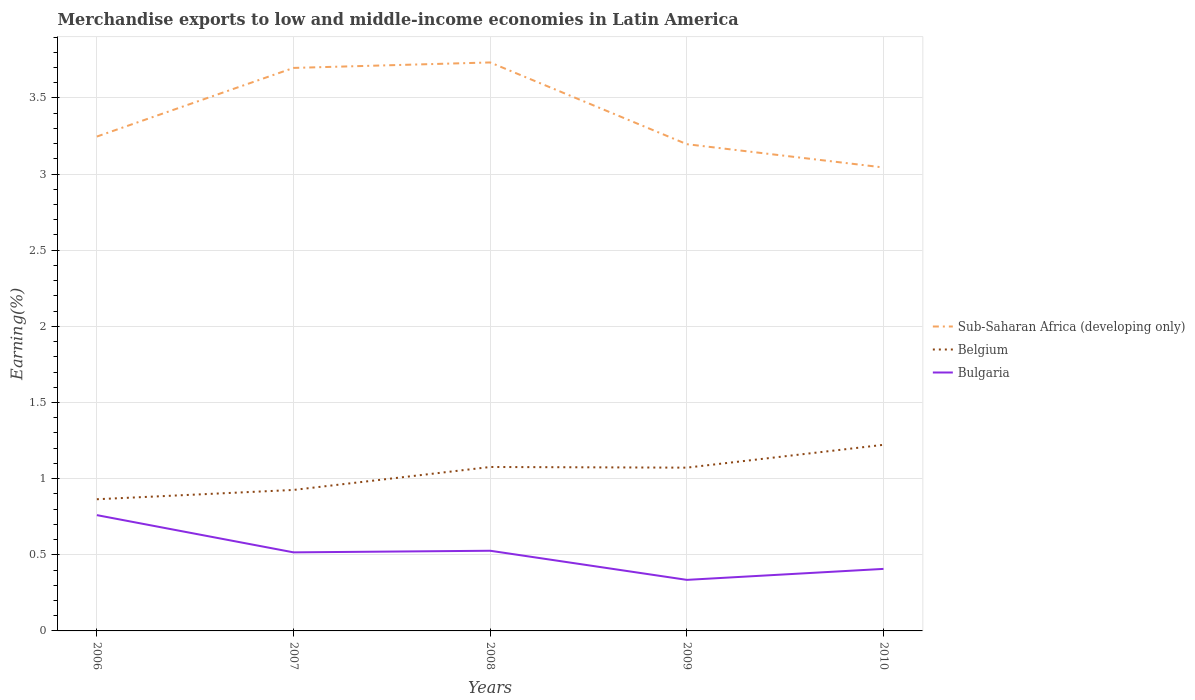Does the line corresponding to Sub-Saharan Africa (developing only) intersect with the line corresponding to Belgium?
Give a very brief answer. No. Is the number of lines equal to the number of legend labels?
Keep it short and to the point. Yes. Across all years, what is the maximum percentage of amount earned from merchandise exports in Bulgaria?
Provide a succinct answer. 0.34. In which year was the percentage of amount earned from merchandise exports in Bulgaria maximum?
Ensure brevity in your answer.  2009. What is the total percentage of amount earned from merchandise exports in Sub-Saharan Africa (developing only) in the graph?
Offer a very short reply. 0.5. What is the difference between the highest and the second highest percentage of amount earned from merchandise exports in Bulgaria?
Make the answer very short. 0.43. What is the difference between the highest and the lowest percentage of amount earned from merchandise exports in Belgium?
Keep it short and to the point. 3. How many years are there in the graph?
Your answer should be very brief. 5. Are the values on the major ticks of Y-axis written in scientific E-notation?
Keep it short and to the point. No. What is the title of the graph?
Offer a terse response. Merchandise exports to low and middle-income economies in Latin America. Does "Northern Mariana Islands" appear as one of the legend labels in the graph?
Offer a very short reply. No. What is the label or title of the X-axis?
Ensure brevity in your answer.  Years. What is the label or title of the Y-axis?
Your answer should be very brief. Earning(%). What is the Earning(%) of Sub-Saharan Africa (developing only) in 2006?
Offer a very short reply. 3.25. What is the Earning(%) of Belgium in 2006?
Provide a succinct answer. 0.86. What is the Earning(%) of Bulgaria in 2006?
Make the answer very short. 0.76. What is the Earning(%) of Sub-Saharan Africa (developing only) in 2007?
Your response must be concise. 3.7. What is the Earning(%) of Belgium in 2007?
Your answer should be compact. 0.93. What is the Earning(%) in Bulgaria in 2007?
Ensure brevity in your answer.  0.52. What is the Earning(%) in Sub-Saharan Africa (developing only) in 2008?
Ensure brevity in your answer.  3.73. What is the Earning(%) of Belgium in 2008?
Your response must be concise. 1.08. What is the Earning(%) of Bulgaria in 2008?
Keep it short and to the point. 0.53. What is the Earning(%) of Sub-Saharan Africa (developing only) in 2009?
Give a very brief answer. 3.2. What is the Earning(%) of Belgium in 2009?
Give a very brief answer. 1.07. What is the Earning(%) in Bulgaria in 2009?
Your answer should be very brief. 0.34. What is the Earning(%) of Sub-Saharan Africa (developing only) in 2010?
Give a very brief answer. 3.04. What is the Earning(%) in Belgium in 2010?
Offer a very short reply. 1.22. What is the Earning(%) in Bulgaria in 2010?
Give a very brief answer. 0.41. Across all years, what is the maximum Earning(%) in Sub-Saharan Africa (developing only)?
Offer a terse response. 3.73. Across all years, what is the maximum Earning(%) in Belgium?
Keep it short and to the point. 1.22. Across all years, what is the maximum Earning(%) of Bulgaria?
Keep it short and to the point. 0.76. Across all years, what is the minimum Earning(%) of Sub-Saharan Africa (developing only)?
Ensure brevity in your answer.  3.04. Across all years, what is the minimum Earning(%) in Belgium?
Your response must be concise. 0.86. Across all years, what is the minimum Earning(%) of Bulgaria?
Provide a succinct answer. 0.34. What is the total Earning(%) in Sub-Saharan Africa (developing only) in the graph?
Offer a terse response. 16.92. What is the total Earning(%) in Belgium in the graph?
Offer a terse response. 5.16. What is the total Earning(%) in Bulgaria in the graph?
Offer a very short reply. 2.55. What is the difference between the Earning(%) of Sub-Saharan Africa (developing only) in 2006 and that in 2007?
Your answer should be compact. -0.45. What is the difference between the Earning(%) in Belgium in 2006 and that in 2007?
Offer a terse response. -0.06. What is the difference between the Earning(%) in Bulgaria in 2006 and that in 2007?
Give a very brief answer. 0.24. What is the difference between the Earning(%) of Sub-Saharan Africa (developing only) in 2006 and that in 2008?
Your answer should be compact. -0.49. What is the difference between the Earning(%) of Belgium in 2006 and that in 2008?
Offer a very short reply. -0.21. What is the difference between the Earning(%) in Bulgaria in 2006 and that in 2008?
Offer a terse response. 0.23. What is the difference between the Earning(%) of Sub-Saharan Africa (developing only) in 2006 and that in 2009?
Your answer should be compact. 0.05. What is the difference between the Earning(%) of Belgium in 2006 and that in 2009?
Offer a terse response. -0.21. What is the difference between the Earning(%) of Bulgaria in 2006 and that in 2009?
Make the answer very short. 0.43. What is the difference between the Earning(%) in Sub-Saharan Africa (developing only) in 2006 and that in 2010?
Your answer should be very brief. 0.2. What is the difference between the Earning(%) in Belgium in 2006 and that in 2010?
Provide a short and direct response. -0.36. What is the difference between the Earning(%) in Bulgaria in 2006 and that in 2010?
Give a very brief answer. 0.35. What is the difference between the Earning(%) in Sub-Saharan Africa (developing only) in 2007 and that in 2008?
Keep it short and to the point. -0.04. What is the difference between the Earning(%) of Belgium in 2007 and that in 2008?
Ensure brevity in your answer.  -0.15. What is the difference between the Earning(%) in Bulgaria in 2007 and that in 2008?
Give a very brief answer. -0.01. What is the difference between the Earning(%) of Sub-Saharan Africa (developing only) in 2007 and that in 2009?
Make the answer very short. 0.5. What is the difference between the Earning(%) of Belgium in 2007 and that in 2009?
Provide a short and direct response. -0.15. What is the difference between the Earning(%) of Bulgaria in 2007 and that in 2009?
Your answer should be compact. 0.18. What is the difference between the Earning(%) of Sub-Saharan Africa (developing only) in 2007 and that in 2010?
Offer a terse response. 0.65. What is the difference between the Earning(%) in Belgium in 2007 and that in 2010?
Offer a very short reply. -0.3. What is the difference between the Earning(%) of Bulgaria in 2007 and that in 2010?
Your answer should be compact. 0.11. What is the difference between the Earning(%) in Sub-Saharan Africa (developing only) in 2008 and that in 2009?
Make the answer very short. 0.54. What is the difference between the Earning(%) in Belgium in 2008 and that in 2009?
Give a very brief answer. 0. What is the difference between the Earning(%) of Bulgaria in 2008 and that in 2009?
Offer a terse response. 0.19. What is the difference between the Earning(%) of Sub-Saharan Africa (developing only) in 2008 and that in 2010?
Provide a succinct answer. 0.69. What is the difference between the Earning(%) in Belgium in 2008 and that in 2010?
Offer a very short reply. -0.15. What is the difference between the Earning(%) in Bulgaria in 2008 and that in 2010?
Your response must be concise. 0.12. What is the difference between the Earning(%) in Sub-Saharan Africa (developing only) in 2009 and that in 2010?
Provide a short and direct response. 0.15. What is the difference between the Earning(%) in Belgium in 2009 and that in 2010?
Ensure brevity in your answer.  -0.15. What is the difference between the Earning(%) in Bulgaria in 2009 and that in 2010?
Your answer should be compact. -0.07. What is the difference between the Earning(%) in Sub-Saharan Africa (developing only) in 2006 and the Earning(%) in Belgium in 2007?
Offer a terse response. 2.32. What is the difference between the Earning(%) of Sub-Saharan Africa (developing only) in 2006 and the Earning(%) of Bulgaria in 2007?
Your answer should be compact. 2.73. What is the difference between the Earning(%) in Belgium in 2006 and the Earning(%) in Bulgaria in 2007?
Offer a terse response. 0.35. What is the difference between the Earning(%) of Sub-Saharan Africa (developing only) in 2006 and the Earning(%) of Belgium in 2008?
Keep it short and to the point. 2.17. What is the difference between the Earning(%) in Sub-Saharan Africa (developing only) in 2006 and the Earning(%) in Bulgaria in 2008?
Offer a very short reply. 2.72. What is the difference between the Earning(%) in Belgium in 2006 and the Earning(%) in Bulgaria in 2008?
Provide a short and direct response. 0.34. What is the difference between the Earning(%) in Sub-Saharan Africa (developing only) in 2006 and the Earning(%) in Belgium in 2009?
Offer a very short reply. 2.17. What is the difference between the Earning(%) in Sub-Saharan Africa (developing only) in 2006 and the Earning(%) in Bulgaria in 2009?
Your answer should be very brief. 2.91. What is the difference between the Earning(%) in Belgium in 2006 and the Earning(%) in Bulgaria in 2009?
Ensure brevity in your answer.  0.53. What is the difference between the Earning(%) in Sub-Saharan Africa (developing only) in 2006 and the Earning(%) in Belgium in 2010?
Keep it short and to the point. 2.02. What is the difference between the Earning(%) of Sub-Saharan Africa (developing only) in 2006 and the Earning(%) of Bulgaria in 2010?
Offer a terse response. 2.84. What is the difference between the Earning(%) of Belgium in 2006 and the Earning(%) of Bulgaria in 2010?
Offer a terse response. 0.46. What is the difference between the Earning(%) in Sub-Saharan Africa (developing only) in 2007 and the Earning(%) in Belgium in 2008?
Provide a succinct answer. 2.62. What is the difference between the Earning(%) in Sub-Saharan Africa (developing only) in 2007 and the Earning(%) in Bulgaria in 2008?
Give a very brief answer. 3.17. What is the difference between the Earning(%) of Belgium in 2007 and the Earning(%) of Bulgaria in 2008?
Your response must be concise. 0.4. What is the difference between the Earning(%) in Sub-Saharan Africa (developing only) in 2007 and the Earning(%) in Belgium in 2009?
Give a very brief answer. 2.62. What is the difference between the Earning(%) of Sub-Saharan Africa (developing only) in 2007 and the Earning(%) of Bulgaria in 2009?
Keep it short and to the point. 3.36. What is the difference between the Earning(%) of Belgium in 2007 and the Earning(%) of Bulgaria in 2009?
Offer a very short reply. 0.59. What is the difference between the Earning(%) in Sub-Saharan Africa (developing only) in 2007 and the Earning(%) in Belgium in 2010?
Keep it short and to the point. 2.48. What is the difference between the Earning(%) in Sub-Saharan Africa (developing only) in 2007 and the Earning(%) in Bulgaria in 2010?
Your response must be concise. 3.29. What is the difference between the Earning(%) in Belgium in 2007 and the Earning(%) in Bulgaria in 2010?
Provide a succinct answer. 0.52. What is the difference between the Earning(%) of Sub-Saharan Africa (developing only) in 2008 and the Earning(%) of Belgium in 2009?
Ensure brevity in your answer.  2.66. What is the difference between the Earning(%) of Sub-Saharan Africa (developing only) in 2008 and the Earning(%) of Bulgaria in 2009?
Your answer should be very brief. 3.4. What is the difference between the Earning(%) of Belgium in 2008 and the Earning(%) of Bulgaria in 2009?
Ensure brevity in your answer.  0.74. What is the difference between the Earning(%) of Sub-Saharan Africa (developing only) in 2008 and the Earning(%) of Belgium in 2010?
Your answer should be very brief. 2.51. What is the difference between the Earning(%) of Sub-Saharan Africa (developing only) in 2008 and the Earning(%) of Bulgaria in 2010?
Your response must be concise. 3.33. What is the difference between the Earning(%) of Belgium in 2008 and the Earning(%) of Bulgaria in 2010?
Provide a succinct answer. 0.67. What is the difference between the Earning(%) in Sub-Saharan Africa (developing only) in 2009 and the Earning(%) in Belgium in 2010?
Ensure brevity in your answer.  1.97. What is the difference between the Earning(%) of Sub-Saharan Africa (developing only) in 2009 and the Earning(%) of Bulgaria in 2010?
Ensure brevity in your answer.  2.79. What is the difference between the Earning(%) in Belgium in 2009 and the Earning(%) in Bulgaria in 2010?
Offer a terse response. 0.66. What is the average Earning(%) in Sub-Saharan Africa (developing only) per year?
Provide a succinct answer. 3.38. What is the average Earning(%) in Belgium per year?
Your answer should be very brief. 1.03. What is the average Earning(%) in Bulgaria per year?
Your response must be concise. 0.51. In the year 2006, what is the difference between the Earning(%) in Sub-Saharan Africa (developing only) and Earning(%) in Belgium?
Ensure brevity in your answer.  2.38. In the year 2006, what is the difference between the Earning(%) in Sub-Saharan Africa (developing only) and Earning(%) in Bulgaria?
Ensure brevity in your answer.  2.49. In the year 2006, what is the difference between the Earning(%) of Belgium and Earning(%) of Bulgaria?
Ensure brevity in your answer.  0.1. In the year 2007, what is the difference between the Earning(%) in Sub-Saharan Africa (developing only) and Earning(%) in Belgium?
Your response must be concise. 2.77. In the year 2007, what is the difference between the Earning(%) of Sub-Saharan Africa (developing only) and Earning(%) of Bulgaria?
Your response must be concise. 3.18. In the year 2007, what is the difference between the Earning(%) in Belgium and Earning(%) in Bulgaria?
Your response must be concise. 0.41. In the year 2008, what is the difference between the Earning(%) in Sub-Saharan Africa (developing only) and Earning(%) in Belgium?
Give a very brief answer. 2.66. In the year 2008, what is the difference between the Earning(%) in Sub-Saharan Africa (developing only) and Earning(%) in Bulgaria?
Your answer should be very brief. 3.21. In the year 2008, what is the difference between the Earning(%) of Belgium and Earning(%) of Bulgaria?
Make the answer very short. 0.55. In the year 2009, what is the difference between the Earning(%) in Sub-Saharan Africa (developing only) and Earning(%) in Belgium?
Keep it short and to the point. 2.12. In the year 2009, what is the difference between the Earning(%) of Sub-Saharan Africa (developing only) and Earning(%) of Bulgaria?
Your answer should be very brief. 2.86. In the year 2009, what is the difference between the Earning(%) in Belgium and Earning(%) in Bulgaria?
Offer a very short reply. 0.74. In the year 2010, what is the difference between the Earning(%) in Sub-Saharan Africa (developing only) and Earning(%) in Belgium?
Provide a succinct answer. 1.82. In the year 2010, what is the difference between the Earning(%) of Sub-Saharan Africa (developing only) and Earning(%) of Bulgaria?
Your response must be concise. 2.64. In the year 2010, what is the difference between the Earning(%) of Belgium and Earning(%) of Bulgaria?
Your answer should be very brief. 0.81. What is the ratio of the Earning(%) of Sub-Saharan Africa (developing only) in 2006 to that in 2007?
Keep it short and to the point. 0.88. What is the ratio of the Earning(%) in Belgium in 2006 to that in 2007?
Your answer should be very brief. 0.93. What is the ratio of the Earning(%) of Bulgaria in 2006 to that in 2007?
Ensure brevity in your answer.  1.47. What is the ratio of the Earning(%) in Sub-Saharan Africa (developing only) in 2006 to that in 2008?
Your answer should be very brief. 0.87. What is the ratio of the Earning(%) in Belgium in 2006 to that in 2008?
Provide a short and direct response. 0.8. What is the ratio of the Earning(%) of Bulgaria in 2006 to that in 2008?
Ensure brevity in your answer.  1.44. What is the ratio of the Earning(%) of Sub-Saharan Africa (developing only) in 2006 to that in 2009?
Provide a short and direct response. 1.02. What is the ratio of the Earning(%) in Belgium in 2006 to that in 2009?
Offer a very short reply. 0.81. What is the ratio of the Earning(%) in Bulgaria in 2006 to that in 2009?
Make the answer very short. 2.27. What is the ratio of the Earning(%) of Sub-Saharan Africa (developing only) in 2006 to that in 2010?
Your answer should be very brief. 1.07. What is the ratio of the Earning(%) in Belgium in 2006 to that in 2010?
Ensure brevity in your answer.  0.71. What is the ratio of the Earning(%) in Bulgaria in 2006 to that in 2010?
Offer a terse response. 1.87. What is the ratio of the Earning(%) in Sub-Saharan Africa (developing only) in 2007 to that in 2008?
Provide a succinct answer. 0.99. What is the ratio of the Earning(%) of Belgium in 2007 to that in 2008?
Give a very brief answer. 0.86. What is the ratio of the Earning(%) in Bulgaria in 2007 to that in 2008?
Offer a terse response. 0.98. What is the ratio of the Earning(%) of Sub-Saharan Africa (developing only) in 2007 to that in 2009?
Ensure brevity in your answer.  1.16. What is the ratio of the Earning(%) in Belgium in 2007 to that in 2009?
Your response must be concise. 0.86. What is the ratio of the Earning(%) in Bulgaria in 2007 to that in 2009?
Your answer should be very brief. 1.54. What is the ratio of the Earning(%) of Sub-Saharan Africa (developing only) in 2007 to that in 2010?
Offer a very short reply. 1.21. What is the ratio of the Earning(%) of Belgium in 2007 to that in 2010?
Make the answer very short. 0.76. What is the ratio of the Earning(%) of Bulgaria in 2007 to that in 2010?
Provide a succinct answer. 1.27. What is the ratio of the Earning(%) of Sub-Saharan Africa (developing only) in 2008 to that in 2009?
Your response must be concise. 1.17. What is the ratio of the Earning(%) of Belgium in 2008 to that in 2009?
Your response must be concise. 1. What is the ratio of the Earning(%) of Bulgaria in 2008 to that in 2009?
Your answer should be very brief. 1.57. What is the ratio of the Earning(%) in Sub-Saharan Africa (developing only) in 2008 to that in 2010?
Offer a very short reply. 1.23. What is the ratio of the Earning(%) in Belgium in 2008 to that in 2010?
Give a very brief answer. 0.88. What is the ratio of the Earning(%) in Bulgaria in 2008 to that in 2010?
Make the answer very short. 1.29. What is the ratio of the Earning(%) in Sub-Saharan Africa (developing only) in 2009 to that in 2010?
Give a very brief answer. 1.05. What is the ratio of the Earning(%) in Belgium in 2009 to that in 2010?
Keep it short and to the point. 0.88. What is the ratio of the Earning(%) of Bulgaria in 2009 to that in 2010?
Your answer should be very brief. 0.82. What is the difference between the highest and the second highest Earning(%) of Sub-Saharan Africa (developing only)?
Your response must be concise. 0.04. What is the difference between the highest and the second highest Earning(%) of Belgium?
Give a very brief answer. 0.15. What is the difference between the highest and the second highest Earning(%) in Bulgaria?
Keep it short and to the point. 0.23. What is the difference between the highest and the lowest Earning(%) in Sub-Saharan Africa (developing only)?
Offer a terse response. 0.69. What is the difference between the highest and the lowest Earning(%) of Belgium?
Offer a very short reply. 0.36. What is the difference between the highest and the lowest Earning(%) of Bulgaria?
Offer a very short reply. 0.43. 